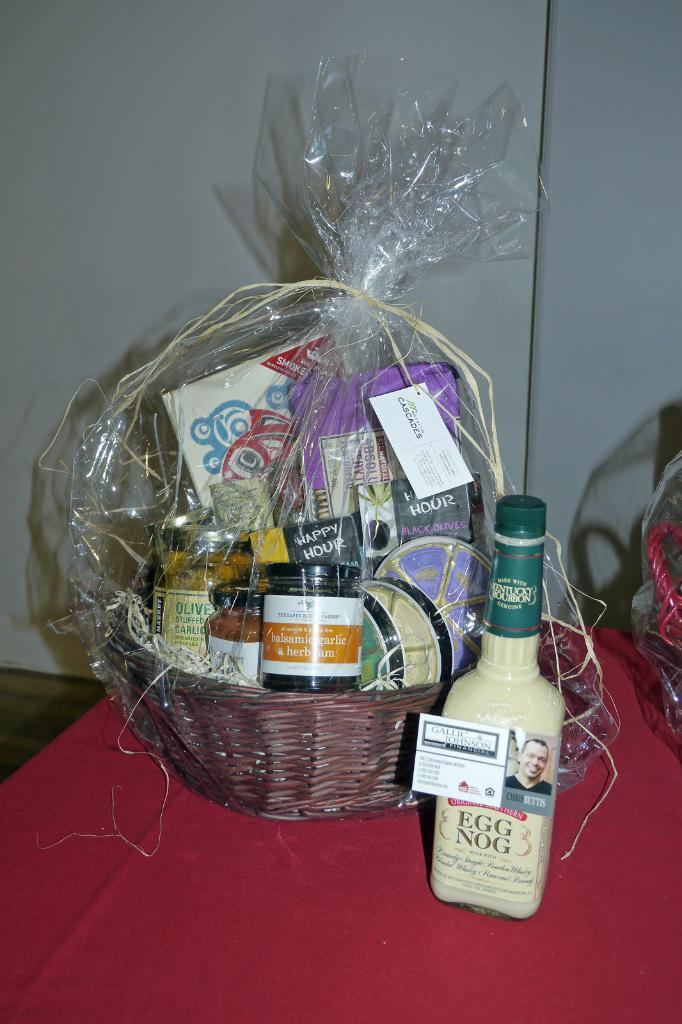<image>
Present a compact description of the photo's key features. A bottle of egg nog is on a table near a gift basket. 